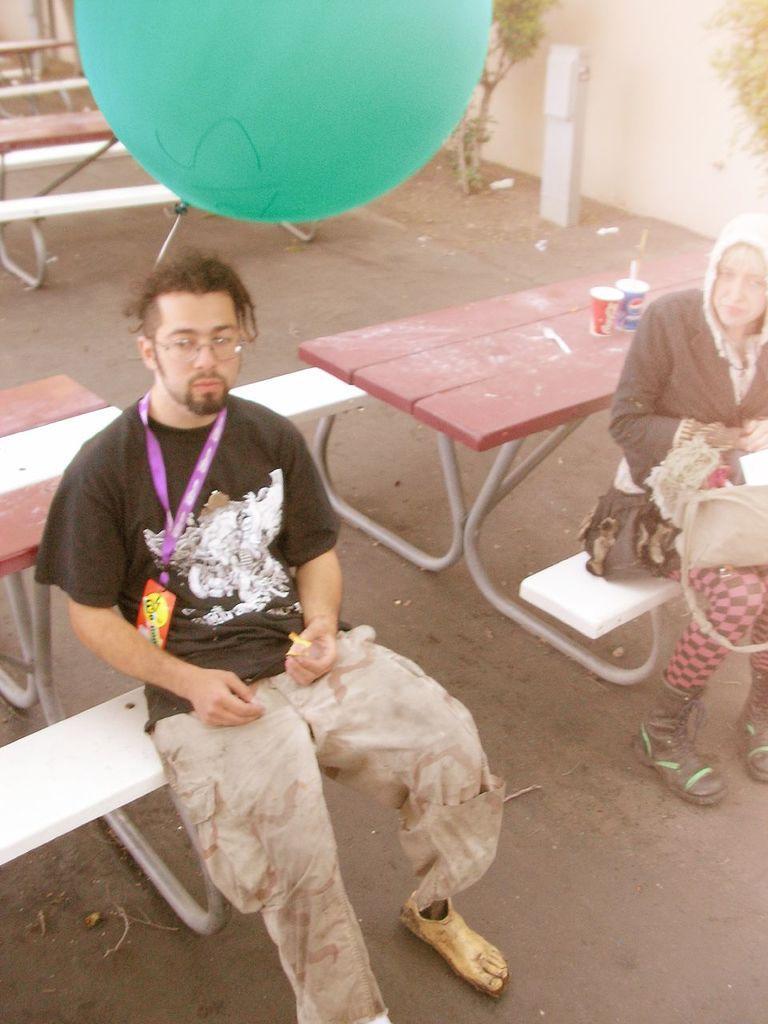In one or two sentences, can you explain what this image depicts? In this picture we can see a man and a woman sitting on benches, two glasses on a table, balloon, id card, bag, tables on the ground and in the background we can see the wall and trees. 